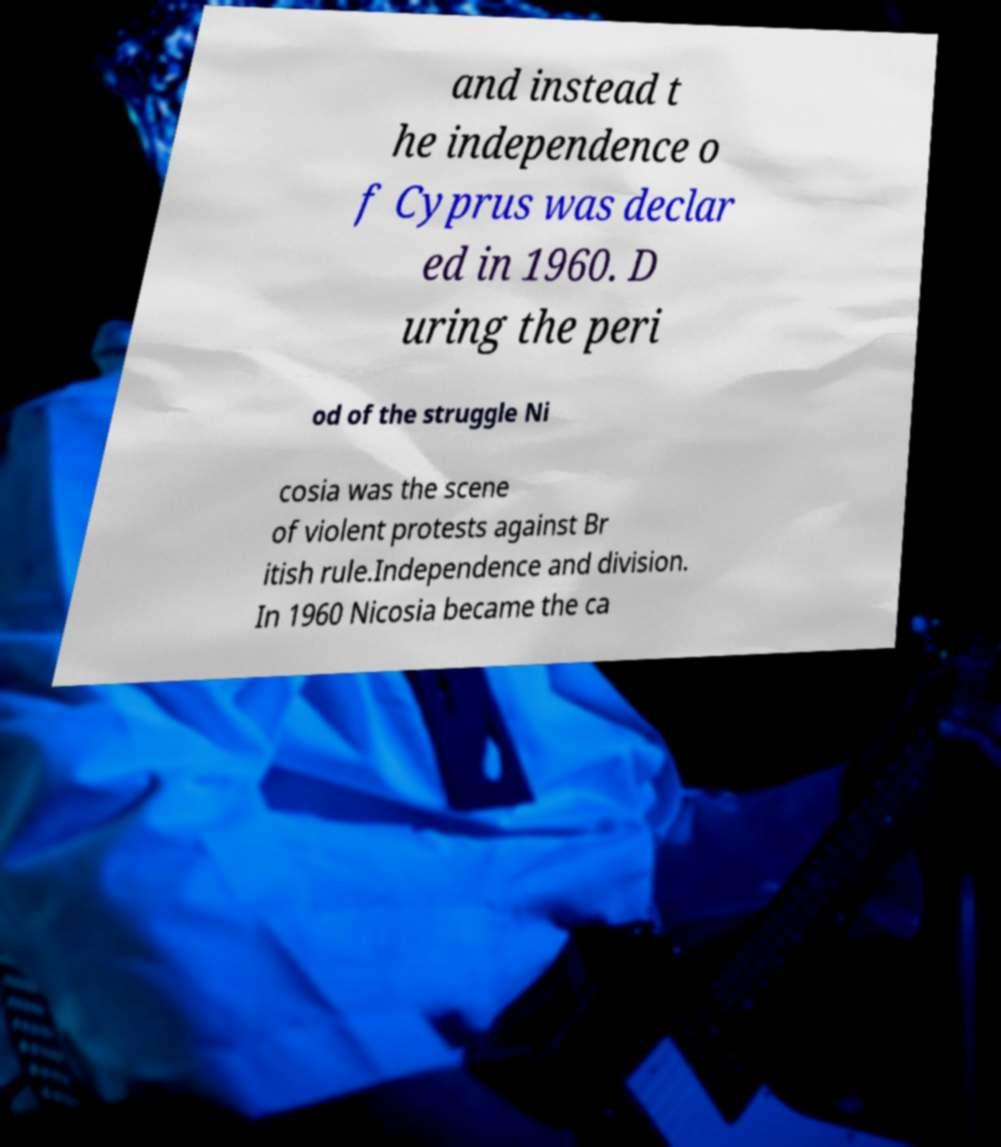What messages or text are displayed in this image? I need them in a readable, typed format. and instead t he independence o f Cyprus was declar ed in 1960. D uring the peri od of the struggle Ni cosia was the scene of violent protests against Br itish rule.Independence and division. In 1960 Nicosia became the ca 